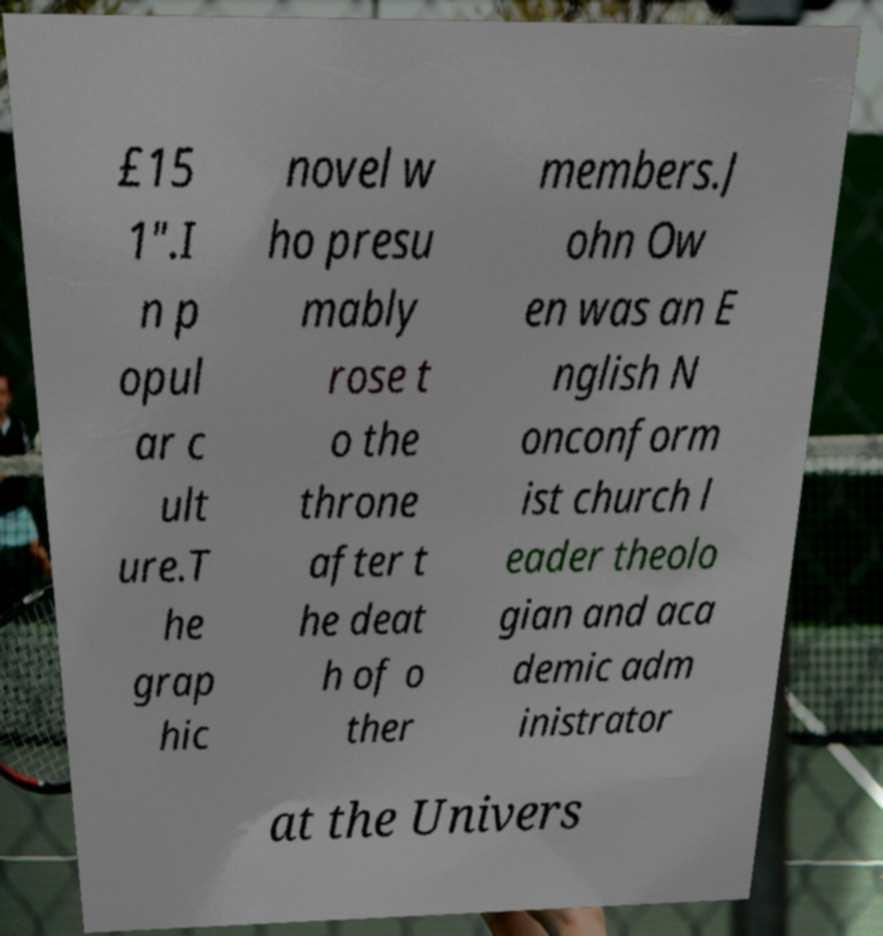Please identify and transcribe the text found in this image. £15 1".I n p opul ar c ult ure.T he grap hic novel w ho presu mably rose t o the throne after t he deat h of o ther members.J ohn Ow en was an E nglish N onconform ist church l eader theolo gian and aca demic adm inistrator at the Univers 